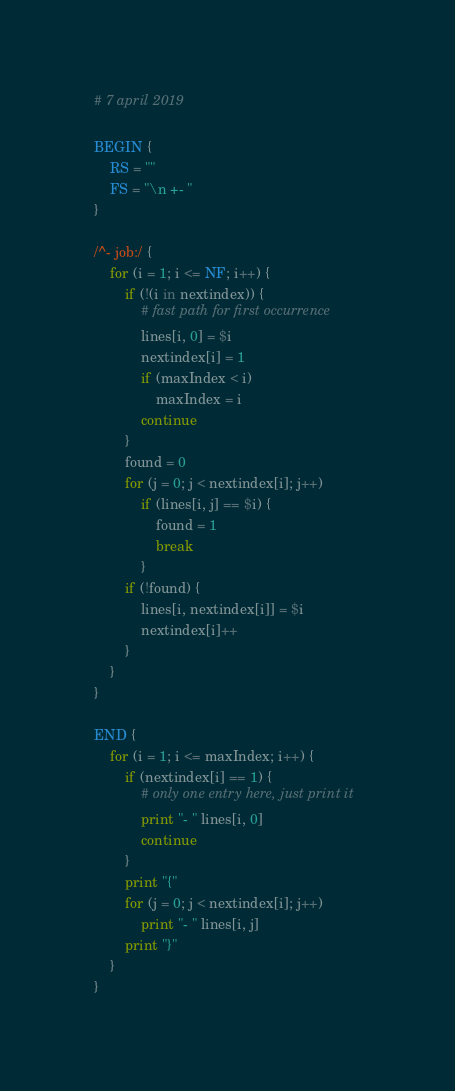<code> <loc_0><loc_0><loc_500><loc_500><_Awk_># 7 april 2019

BEGIN {
	RS = ""
	FS = "\n +- "
}

/^- job:/ {
	for (i = 1; i <= NF; i++) {
		if (!(i in nextindex)) {
			# fast path for first occurrence
			lines[i, 0] = $i
			nextindex[i] = 1
			if (maxIndex < i)
				maxIndex = i
			continue
		}
		found = 0
		for (j = 0; j < nextindex[i]; j++)
			if (lines[i, j] == $i) {
				found = 1
				break
			}
		if (!found) {
			lines[i, nextindex[i]] = $i
			nextindex[i]++
		}
	}
}

END {
	for (i = 1; i <= maxIndex; i++) {
		if (nextindex[i] == 1) {
			# only one entry here, just print it
			print "- " lines[i, 0]
			continue
		}
		print "{"
		for (j = 0; j < nextindex[i]; j++)
			print "- " lines[i, j]
		print "}"
	}
}
</code> 